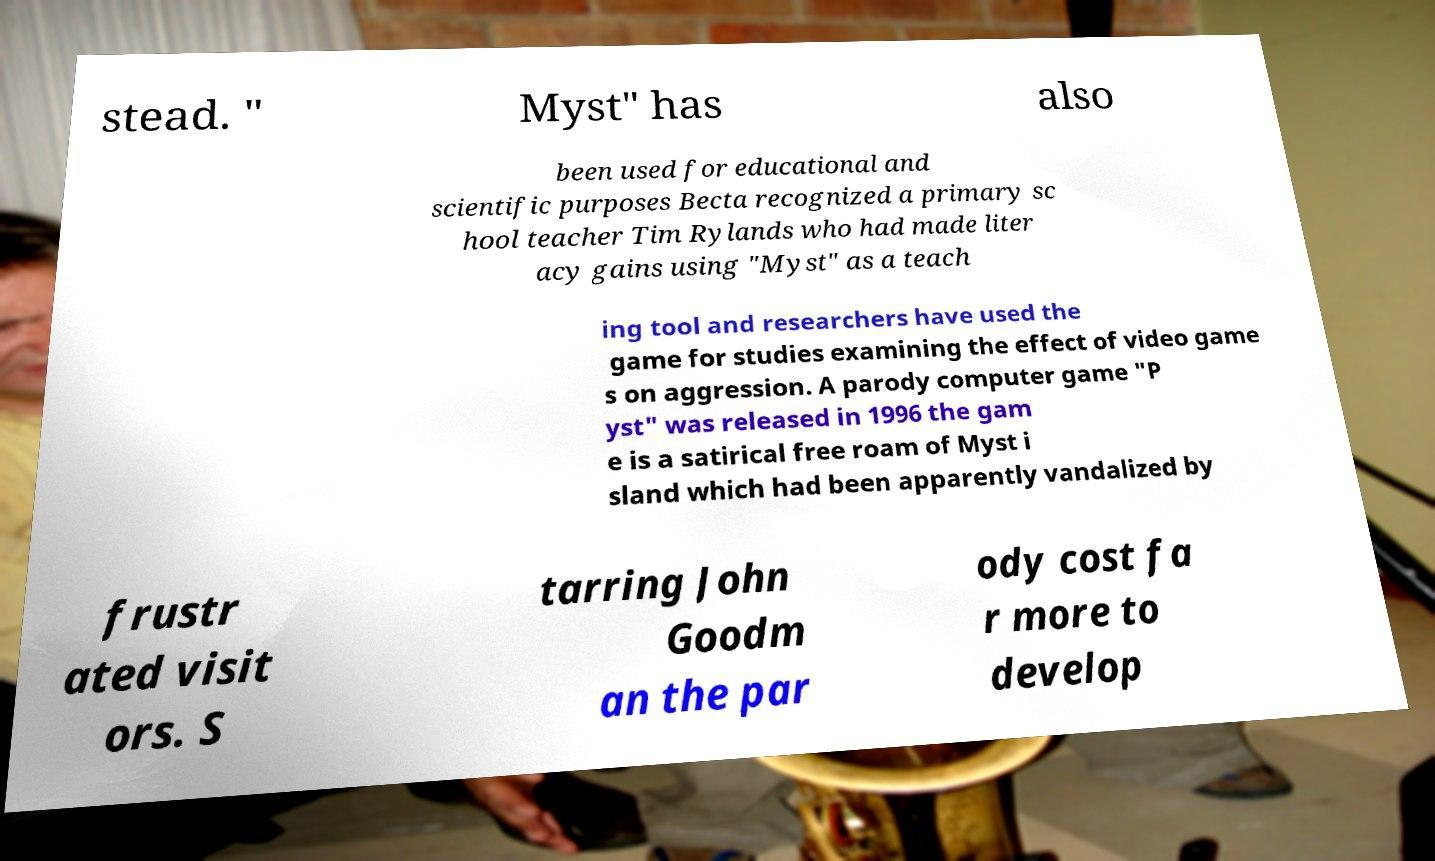Could you extract and type out the text from this image? stead. " Myst" has also been used for educational and scientific purposes Becta recognized a primary sc hool teacher Tim Rylands who had made liter acy gains using "Myst" as a teach ing tool and researchers have used the game for studies examining the effect of video game s on aggression. A parody computer game "P yst" was released in 1996 the gam e is a satirical free roam of Myst i sland which had been apparently vandalized by frustr ated visit ors. S tarring John Goodm an the par ody cost fa r more to develop 